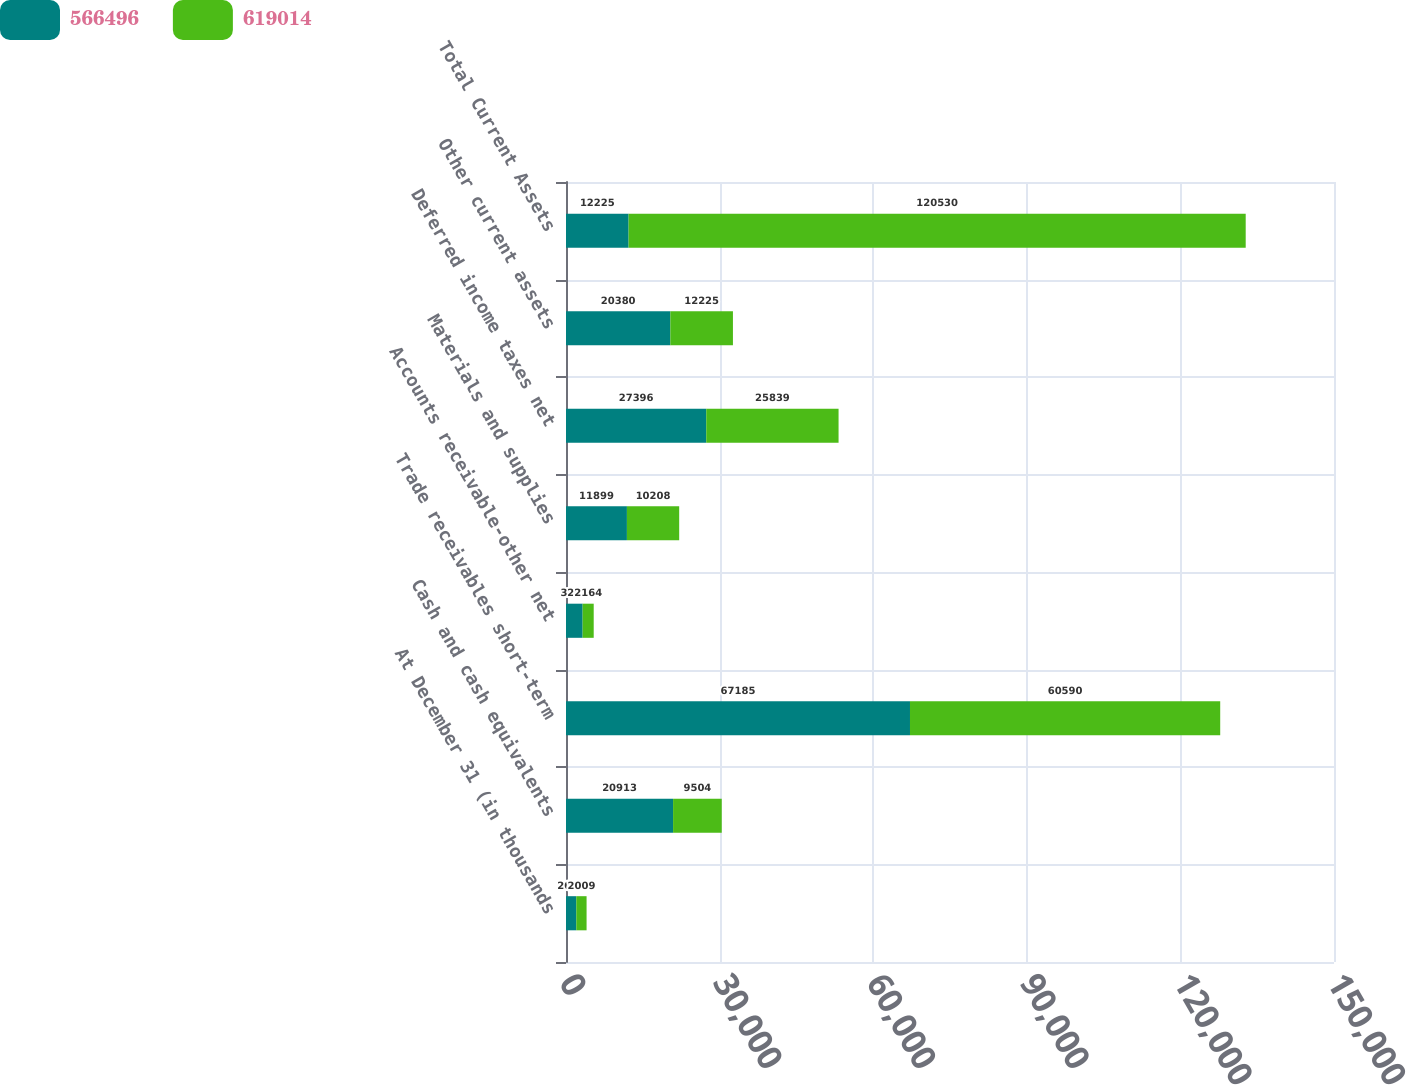Convert chart. <chart><loc_0><loc_0><loc_500><loc_500><stacked_bar_chart><ecel><fcel>At December 31 (in thousands<fcel>Cash and cash equivalents<fcel>Trade receivables short-term<fcel>Accounts receivable-other net<fcel>Materials and supplies<fcel>Deferred income taxes net<fcel>Other current assets<fcel>Total Current Assets<nl><fcel>566496<fcel>2010<fcel>20913<fcel>67185<fcel>3248<fcel>11899<fcel>27396<fcel>20380<fcel>12225<nl><fcel>619014<fcel>2009<fcel>9504<fcel>60590<fcel>2164<fcel>10208<fcel>25839<fcel>12225<fcel>120530<nl></chart> 